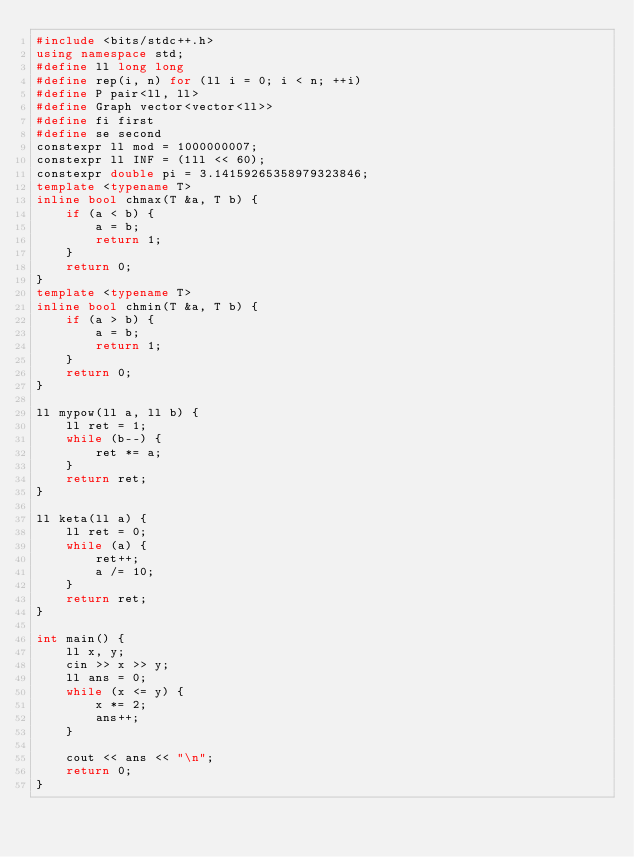<code> <loc_0><loc_0><loc_500><loc_500><_C++_>#include <bits/stdc++.h>
using namespace std;
#define ll long long
#define rep(i, n) for (ll i = 0; i < n; ++i)
#define P pair<ll, ll>
#define Graph vector<vector<ll>>
#define fi first
#define se second
constexpr ll mod = 1000000007;
constexpr ll INF = (1ll << 60);
constexpr double pi = 3.14159265358979323846;
template <typename T>
inline bool chmax(T &a, T b) {
    if (a < b) {
        a = b;
        return 1;
    }
    return 0;
}
template <typename T>
inline bool chmin(T &a, T b) {
    if (a > b) {
        a = b;
        return 1;
    }
    return 0;
}

ll mypow(ll a, ll b) {
    ll ret = 1;
    while (b--) {
        ret *= a;
    }
    return ret;
}

ll keta(ll a) {
    ll ret = 0;
    while (a) {
        ret++;
        a /= 10;
    }
    return ret;
}

int main() {
    ll x, y;
    cin >> x >> y;
    ll ans = 0;
    while (x <= y) {
        x *= 2;
        ans++;
    }

    cout << ans << "\n";
    return 0;
}</code> 